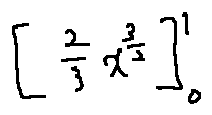Convert formula to latex. <formula><loc_0><loc_0><loc_500><loc_500>[ \frac { 2 } { 3 } x ^ { \frac { 3 } { 2 } } ] _ { 0 } ^ { 1 }</formula> 